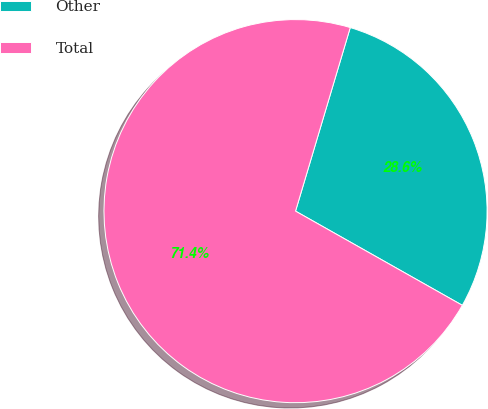Convert chart. <chart><loc_0><loc_0><loc_500><loc_500><pie_chart><fcel>Other<fcel>Total<nl><fcel>28.57%<fcel>71.43%<nl></chart> 